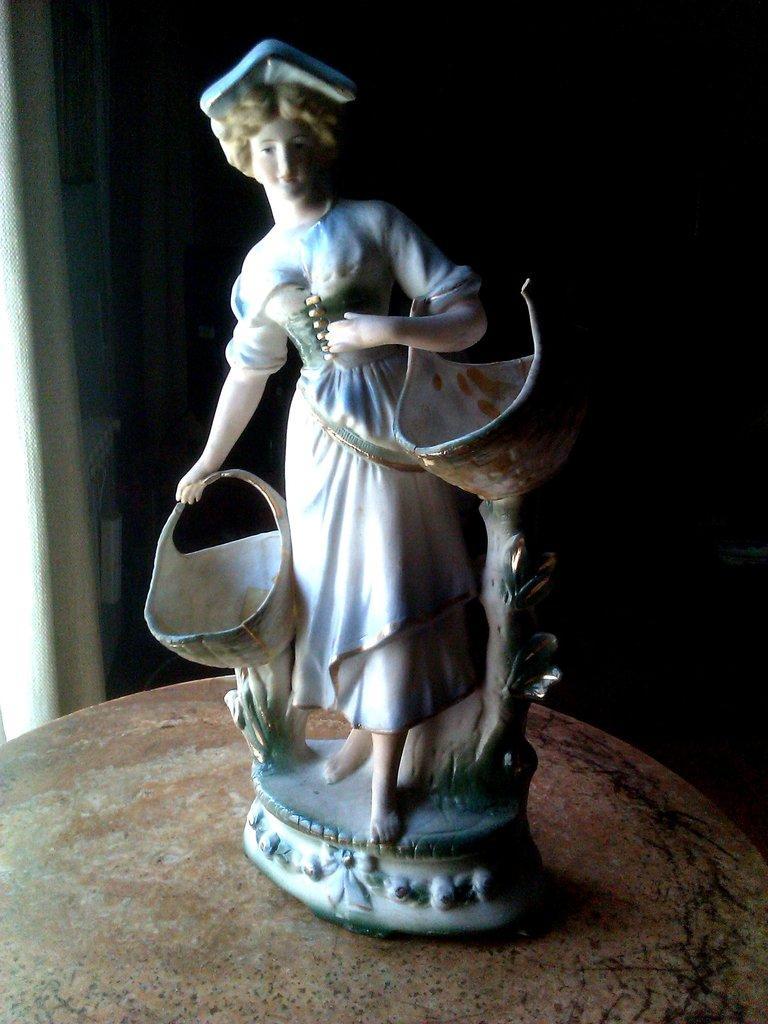How would you summarize this image in a sentence or two? In this picture we can see a table, there is a figurine present on the table. 